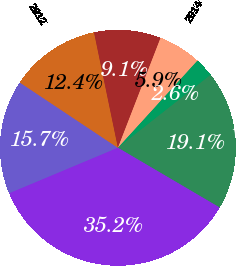Convert chart to OTSL. <chart><loc_0><loc_0><loc_500><loc_500><pie_chart><fcel>2011<fcel>2012<fcel>2013<fcel>2014<fcel>2015<fcel>Thereafter<fcel>Total minimum payments<nl><fcel>15.66%<fcel>12.4%<fcel>9.14%<fcel>5.88%<fcel>2.62%<fcel>19.06%<fcel>35.23%<nl></chart> 